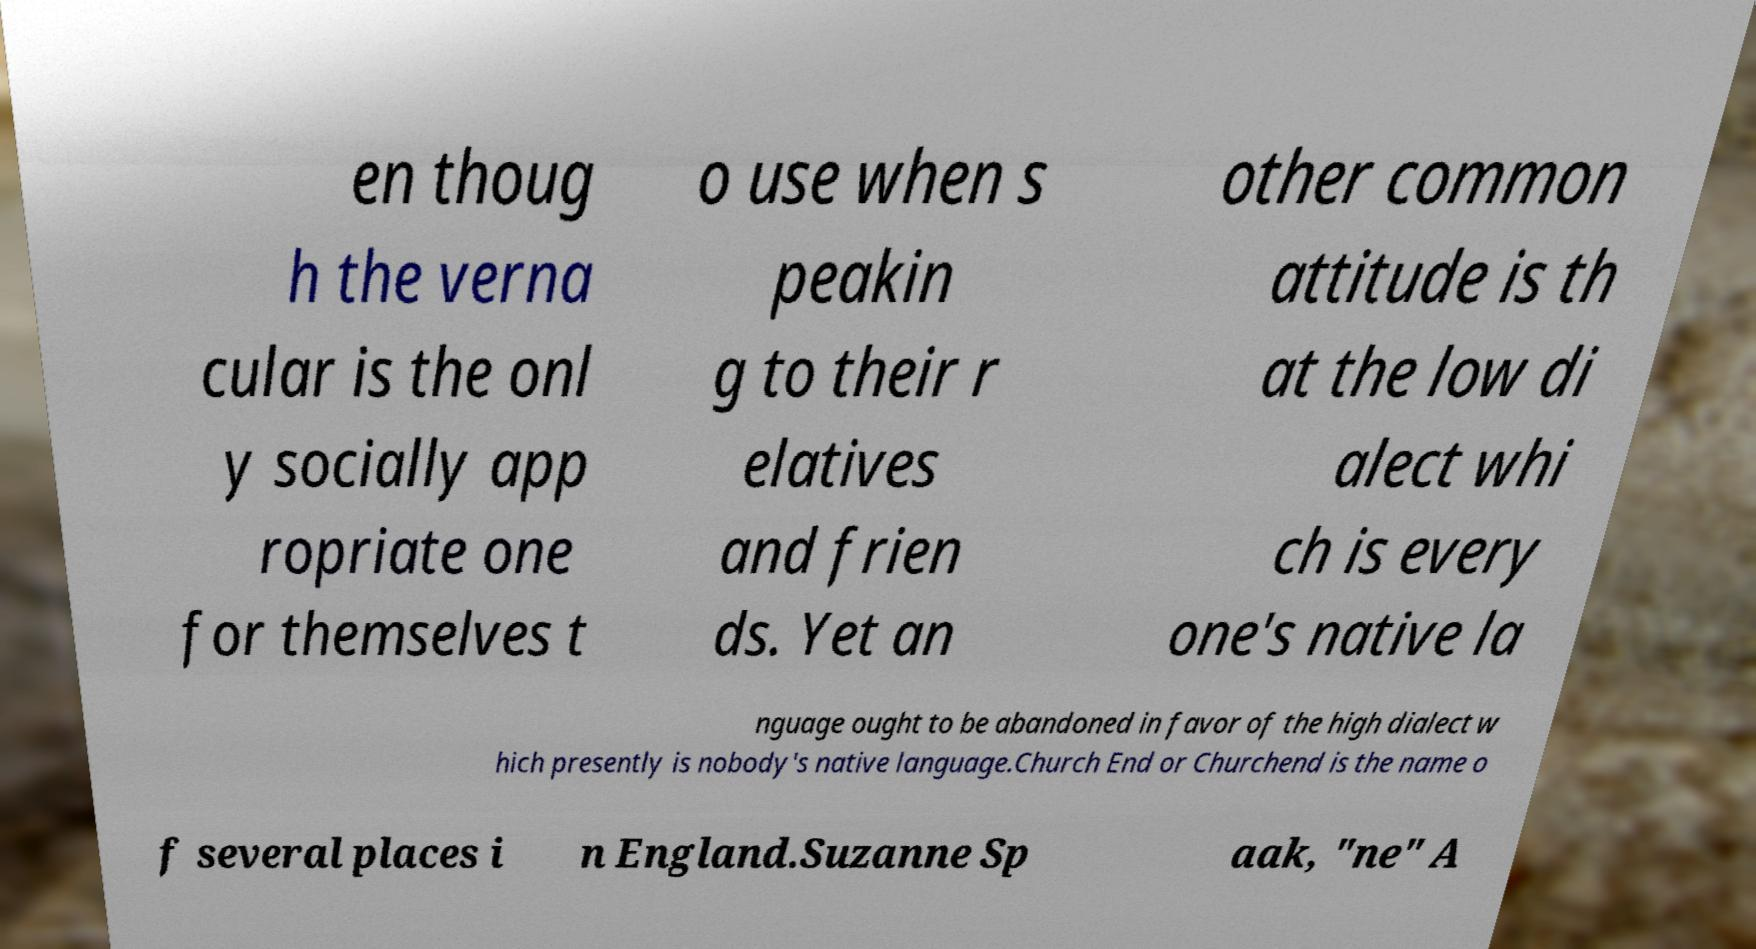Can you read and provide the text displayed in the image?This photo seems to have some interesting text. Can you extract and type it out for me? en thoug h the verna cular is the onl y socially app ropriate one for themselves t o use when s peakin g to their r elatives and frien ds. Yet an other common attitude is th at the low di alect whi ch is every one's native la nguage ought to be abandoned in favor of the high dialect w hich presently is nobody's native language.Church End or Churchend is the name o f several places i n England.Suzanne Sp aak, "ne" A 